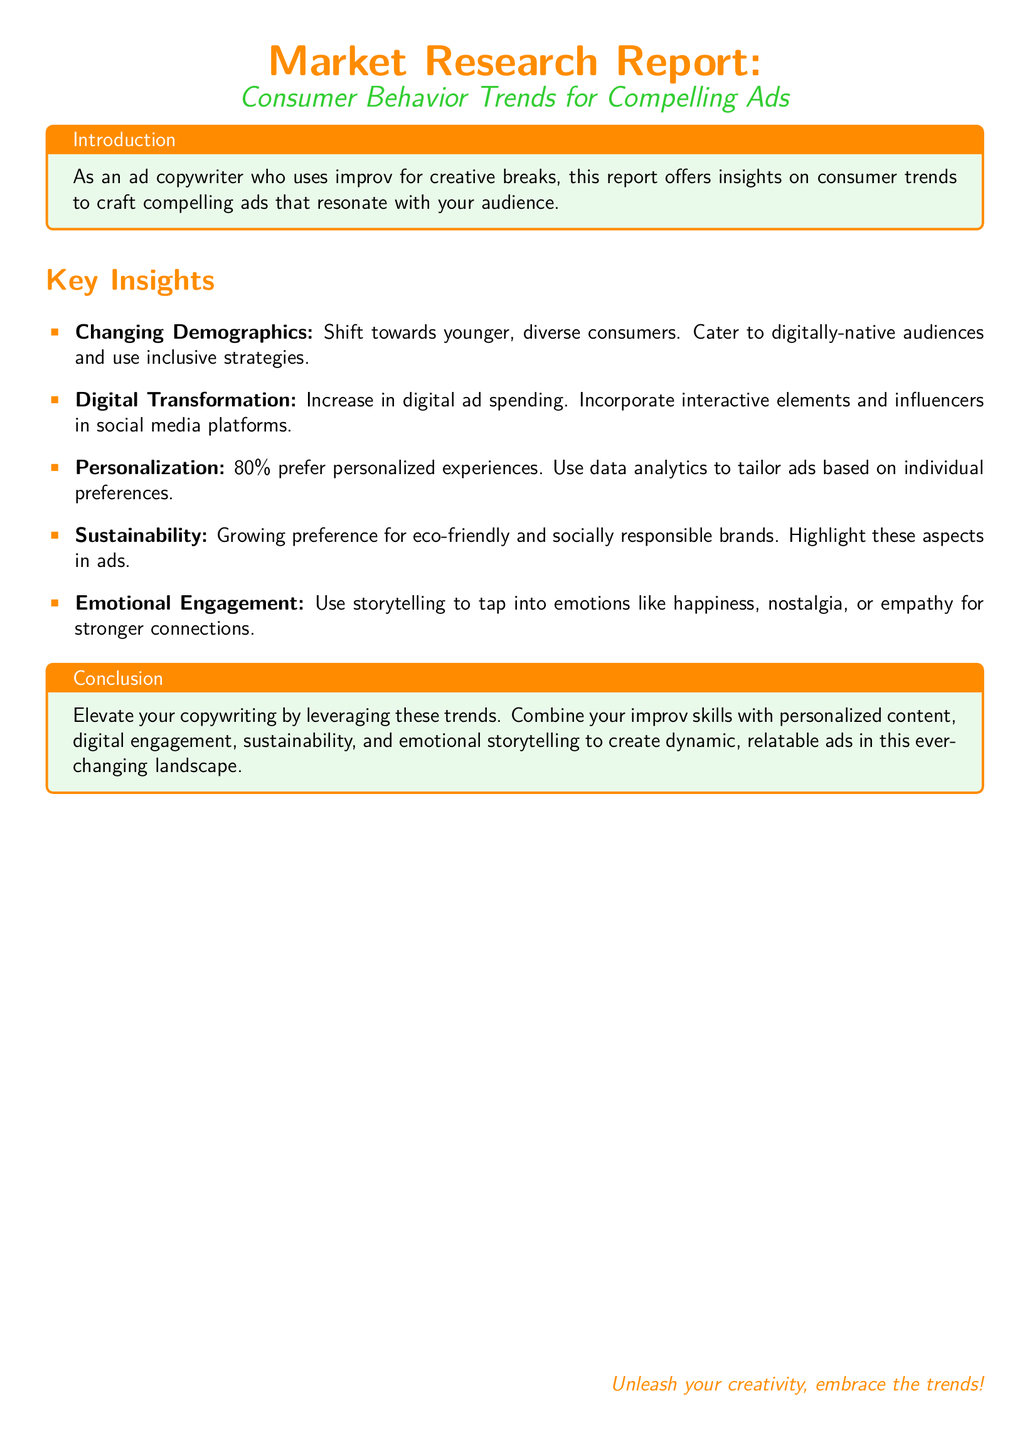What is the main focus of the report? The report focuses on consumer behavior trends to assist in crafting compelling advertisements.
Answer: consumer behavior trends What percentage of consumers prefer personalized experiences? According to the report, 80% of consumers prefer personalized experiences.
Answer: 80% What is a key strategy suggested for addressing changing demographics? The report suggests catering to digitally-native audiences and using inclusive strategies.
Answer: inclusive strategies What is highlighted as important in ads to resonate with consumers' emotions? The report recommends using storytelling to tap into emotions like happiness, nostalgia, or empathy.
Answer: storytelling What type of brands do consumers show a growing preference for? Consumers are showing a growing preference for eco-friendly and socially responsible brands.
Answer: eco-friendly brands Which digital element is emphasized for ad spending transformation? The emphasis is on incorporating interactive elements and influencers in social media platforms.
Answer: interactive elements What creative outlet does the copywriter engage in? The copywriter engages in improv as a creative outlet.
Answer: improv What is the report's suggestion for combining skills in copywriting? The report suggests combining improv skills with personalized content and emotional storytelling.
Answer: personalized content and emotional storytelling 